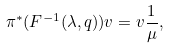<formula> <loc_0><loc_0><loc_500><loc_500>\pi ^ { * } ( F ^ { - 1 } ( \lambda , q ) ) v = v \frac { 1 } { \mu } ,</formula> 